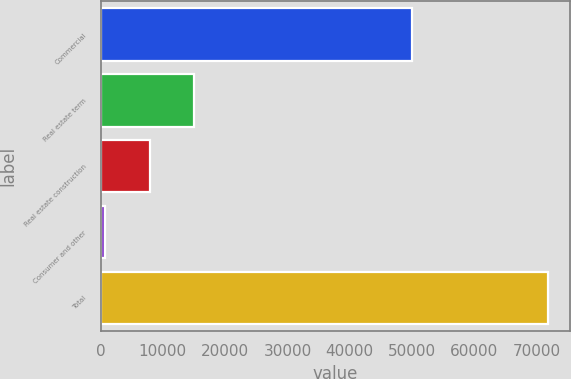<chart> <loc_0><loc_0><loc_500><loc_500><bar_chart><fcel>Commercial<fcel>Real estate term<fcel>Real estate construction<fcel>Consumer and other<fcel>Total<nl><fcel>49985<fcel>14965.6<fcel>7861.3<fcel>757<fcel>71800<nl></chart> 